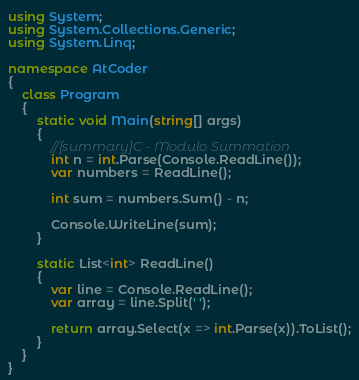<code> <loc_0><loc_0><loc_500><loc_500><_C#_>using System;
using System.Collections.Generic;
using System.Linq;

namespace AtCoder
{
    class Program
    {
        static void Main(string[] args)
        {
            //[summary]C - Modulo Summation
            int n = int.Parse(Console.ReadLine());
            var numbers = ReadLine();
            
            int sum = numbers.Sum() - n;
            
            Console.WriteLine(sum);
        }
        
        static List<int> ReadLine()
        {
            var line = Console.ReadLine();
            var array = line.Split(' ');

            return array.Select(x => int.Parse(x)).ToList();
        }
    }
}</code> 